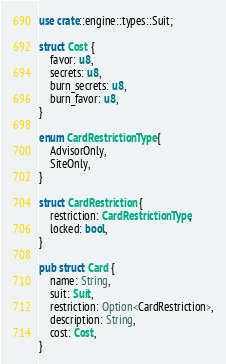<code> <loc_0><loc_0><loc_500><loc_500><_Rust_>use crate::engine::types::Suit;

struct Cost {
    favor: u8,
    secrets: u8,
    burn_secrets: u8,
    burn_favor: u8,
}

enum CardRestrictionType {
    AdvisorOnly,
    SiteOnly,
}

struct CardRestriction {
    restriction: CardRestrictionType,
    locked: bool,
}

pub struct Card {
    name: String,
    suit: Suit,
    restriction: Option<CardRestriction>,
    description: String,
    cost: Cost,
}
</code> 